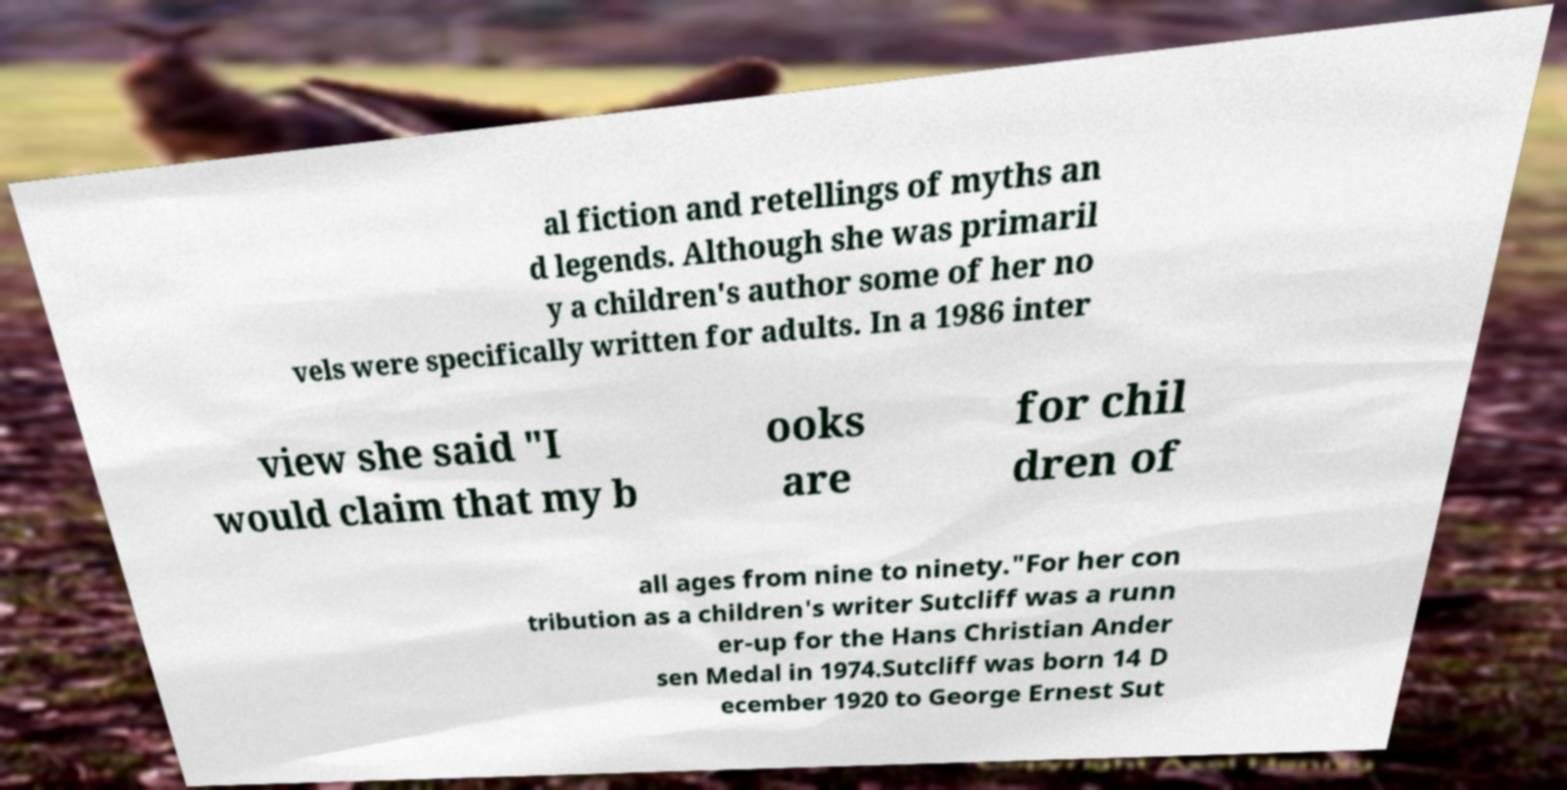Could you assist in decoding the text presented in this image and type it out clearly? al fiction and retellings of myths an d legends. Although she was primaril y a children's author some of her no vels were specifically written for adults. In a 1986 inter view she said "I would claim that my b ooks are for chil dren of all ages from nine to ninety."For her con tribution as a children's writer Sutcliff was a runn er-up for the Hans Christian Ander sen Medal in 1974.Sutcliff was born 14 D ecember 1920 to George Ernest Sut 